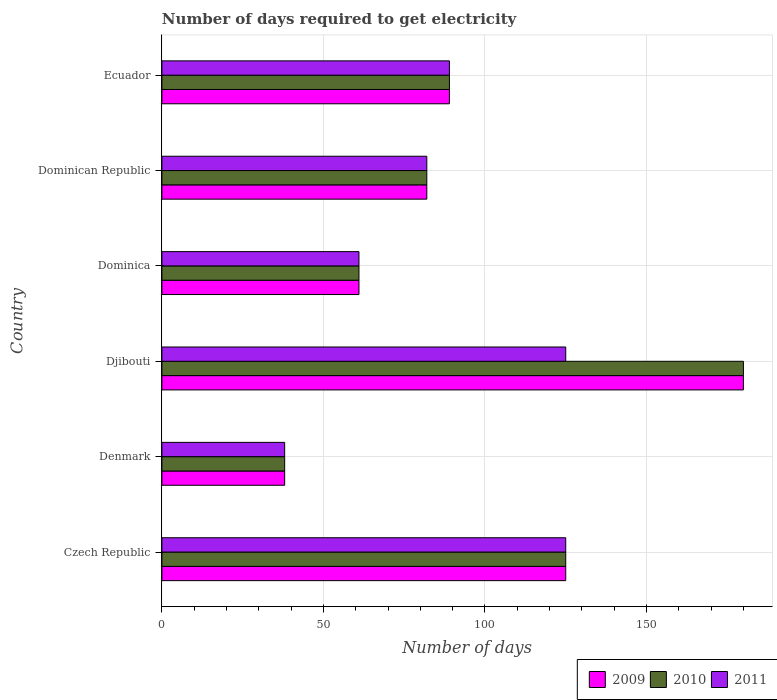How many different coloured bars are there?
Provide a succinct answer. 3. Are the number of bars per tick equal to the number of legend labels?
Your answer should be very brief. Yes. Are the number of bars on each tick of the Y-axis equal?
Keep it short and to the point. Yes. How many bars are there on the 6th tick from the top?
Give a very brief answer. 3. How many bars are there on the 4th tick from the bottom?
Your answer should be very brief. 3. What is the label of the 5th group of bars from the top?
Your response must be concise. Denmark. In how many cases, is the number of bars for a given country not equal to the number of legend labels?
Give a very brief answer. 0. What is the number of days required to get electricity in in 2010 in Denmark?
Offer a terse response. 38. Across all countries, what is the maximum number of days required to get electricity in in 2011?
Make the answer very short. 125. Across all countries, what is the minimum number of days required to get electricity in in 2010?
Keep it short and to the point. 38. In which country was the number of days required to get electricity in in 2009 maximum?
Your answer should be compact. Djibouti. In which country was the number of days required to get electricity in in 2009 minimum?
Your answer should be compact. Denmark. What is the total number of days required to get electricity in in 2009 in the graph?
Your answer should be very brief. 575. What is the average number of days required to get electricity in in 2010 per country?
Provide a short and direct response. 95.83. What is the difference between the number of days required to get electricity in in 2011 and number of days required to get electricity in in 2010 in Dominican Republic?
Your response must be concise. 0. In how many countries, is the number of days required to get electricity in in 2009 greater than 60 days?
Keep it short and to the point. 5. What is the ratio of the number of days required to get electricity in in 2009 in Denmark to that in Ecuador?
Ensure brevity in your answer.  0.43. Is the difference between the number of days required to get electricity in in 2011 in Czech Republic and Dominica greater than the difference between the number of days required to get electricity in in 2010 in Czech Republic and Dominica?
Your answer should be compact. No. What is the difference between the highest and the second highest number of days required to get electricity in in 2011?
Provide a short and direct response. 0. What is the difference between the highest and the lowest number of days required to get electricity in in 2011?
Make the answer very short. 87. In how many countries, is the number of days required to get electricity in in 2010 greater than the average number of days required to get electricity in in 2010 taken over all countries?
Your answer should be compact. 2. What does the 3rd bar from the top in Czech Republic represents?
Keep it short and to the point. 2009. What does the 3rd bar from the bottom in Czech Republic represents?
Keep it short and to the point. 2011. Is it the case that in every country, the sum of the number of days required to get electricity in in 2010 and number of days required to get electricity in in 2009 is greater than the number of days required to get electricity in in 2011?
Your answer should be compact. Yes. Are all the bars in the graph horizontal?
Your response must be concise. Yes. How many countries are there in the graph?
Provide a short and direct response. 6. How are the legend labels stacked?
Your answer should be compact. Horizontal. What is the title of the graph?
Make the answer very short. Number of days required to get electricity. Does "2003" appear as one of the legend labels in the graph?
Your answer should be compact. No. What is the label or title of the X-axis?
Offer a very short reply. Number of days. What is the label or title of the Y-axis?
Offer a terse response. Country. What is the Number of days in 2009 in Czech Republic?
Provide a succinct answer. 125. What is the Number of days in 2010 in Czech Republic?
Your answer should be compact. 125. What is the Number of days of 2011 in Czech Republic?
Your response must be concise. 125. What is the Number of days in 2009 in Denmark?
Your response must be concise. 38. What is the Number of days of 2009 in Djibouti?
Your response must be concise. 180. What is the Number of days in 2010 in Djibouti?
Your answer should be compact. 180. What is the Number of days in 2011 in Djibouti?
Provide a succinct answer. 125. What is the Number of days in 2009 in Dominica?
Provide a succinct answer. 61. What is the Number of days in 2010 in Dominica?
Your answer should be very brief. 61. What is the Number of days of 2011 in Dominica?
Ensure brevity in your answer.  61. What is the Number of days in 2010 in Dominican Republic?
Your answer should be very brief. 82. What is the Number of days in 2009 in Ecuador?
Offer a very short reply. 89. What is the Number of days of 2010 in Ecuador?
Provide a short and direct response. 89. What is the Number of days in 2011 in Ecuador?
Keep it short and to the point. 89. Across all countries, what is the maximum Number of days in 2009?
Your answer should be compact. 180. Across all countries, what is the maximum Number of days of 2010?
Give a very brief answer. 180. Across all countries, what is the maximum Number of days of 2011?
Your response must be concise. 125. Across all countries, what is the minimum Number of days in 2009?
Your answer should be compact. 38. Across all countries, what is the minimum Number of days in 2010?
Your answer should be very brief. 38. Across all countries, what is the minimum Number of days in 2011?
Provide a succinct answer. 38. What is the total Number of days of 2009 in the graph?
Provide a succinct answer. 575. What is the total Number of days of 2010 in the graph?
Offer a very short reply. 575. What is the total Number of days in 2011 in the graph?
Give a very brief answer. 520. What is the difference between the Number of days in 2009 in Czech Republic and that in Denmark?
Your answer should be very brief. 87. What is the difference between the Number of days in 2009 in Czech Republic and that in Djibouti?
Your answer should be compact. -55. What is the difference between the Number of days in 2010 in Czech Republic and that in Djibouti?
Offer a very short reply. -55. What is the difference between the Number of days of 2011 in Czech Republic and that in Djibouti?
Your response must be concise. 0. What is the difference between the Number of days in 2009 in Czech Republic and that in Dominica?
Your answer should be very brief. 64. What is the difference between the Number of days of 2011 in Czech Republic and that in Dominican Republic?
Provide a short and direct response. 43. What is the difference between the Number of days of 2009 in Czech Republic and that in Ecuador?
Offer a terse response. 36. What is the difference between the Number of days of 2011 in Czech Republic and that in Ecuador?
Your response must be concise. 36. What is the difference between the Number of days in 2009 in Denmark and that in Djibouti?
Offer a very short reply. -142. What is the difference between the Number of days of 2010 in Denmark and that in Djibouti?
Provide a succinct answer. -142. What is the difference between the Number of days in 2011 in Denmark and that in Djibouti?
Your answer should be compact. -87. What is the difference between the Number of days of 2009 in Denmark and that in Dominican Republic?
Offer a very short reply. -44. What is the difference between the Number of days in 2010 in Denmark and that in Dominican Republic?
Give a very brief answer. -44. What is the difference between the Number of days in 2011 in Denmark and that in Dominican Republic?
Your answer should be compact. -44. What is the difference between the Number of days in 2009 in Denmark and that in Ecuador?
Your answer should be very brief. -51. What is the difference between the Number of days of 2010 in Denmark and that in Ecuador?
Offer a terse response. -51. What is the difference between the Number of days in 2011 in Denmark and that in Ecuador?
Give a very brief answer. -51. What is the difference between the Number of days of 2009 in Djibouti and that in Dominica?
Make the answer very short. 119. What is the difference between the Number of days in 2010 in Djibouti and that in Dominica?
Ensure brevity in your answer.  119. What is the difference between the Number of days of 2011 in Djibouti and that in Dominica?
Offer a terse response. 64. What is the difference between the Number of days in 2011 in Djibouti and that in Dominican Republic?
Offer a very short reply. 43. What is the difference between the Number of days of 2009 in Djibouti and that in Ecuador?
Offer a very short reply. 91. What is the difference between the Number of days of 2010 in Djibouti and that in Ecuador?
Keep it short and to the point. 91. What is the difference between the Number of days in 2010 in Dominica and that in Dominican Republic?
Offer a terse response. -21. What is the difference between the Number of days in 2011 in Dominica and that in Dominican Republic?
Ensure brevity in your answer.  -21. What is the difference between the Number of days of 2010 in Dominica and that in Ecuador?
Keep it short and to the point. -28. What is the difference between the Number of days of 2011 in Dominica and that in Ecuador?
Your answer should be very brief. -28. What is the difference between the Number of days in 2010 in Czech Republic and the Number of days in 2011 in Denmark?
Make the answer very short. 87. What is the difference between the Number of days in 2009 in Czech Republic and the Number of days in 2010 in Djibouti?
Keep it short and to the point. -55. What is the difference between the Number of days in 2010 in Czech Republic and the Number of days in 2011 in Djibouti?
Give a very brief answer. 0. What is the difference between the Number of days of 2009 in Czech Republic and the Number of days of 2010 in Dominican Republic?
Give a very brief answer. 43. What is the difference between the Number of days in 2009 in Czech Republic and the Number of days in 2011 in Dominican Republic?
Make the answer very short. 43. What is the difference between the Number of days of 2010 in Czech Republic and the Number of days of 2011 in Dominican Republic?
Make the answer very short. 43. What is the difference between the Number of days in 2009 in Czech Republic and the Number of days in 2010 in Ecuador?
Your answer should be compact. 36. What is the difference between the Number of days of 2010 in Czech Republic and the Number of days of 2011 in Ecuador?
Keep it short and to the point. 36. What is the difference between the Number of days of 2009 in Denmark and the Number of days of 2010 in Djibouti?
Provide a short and direct response. -142. What is the difference between the Number of days in 2009 in Denmark and the Number of days in 2011 in Djibouti?
Provide a short and direct response. -87. What is the difference between the Number of days in 2010 in Denmark and the Number of days in 2011 in Djibouti?
Make the answer very short. -87. What is the difference between the Number of days of 2009 in Denmark and the Number of days of 2010 in Dominica?
Make the answer very short. -23. What is the difference between the Number of days in 2009 in Denmark and the Number of days in 2011 in Dominica?
Your answer should be compact. -23. What is the difference between the Number of days of 2010 in Denmark and the Number of days of 2011 in Dominica?
Offer a terse response. -23. What is the difference between the Number of days of 2009 in Denmark and the Number of days of 2010 in Dominican Republic?
Your response must be concise. -44. What is the difference between the Number of days of 2009 in Denmark and the Number of days of 2011 in Dominican Republic?
Make the answer very short. -44. What is the difference between the Number of days in 2010 in Denmark and the Number of days in 2011 in Dominican Republic?
Your answer should be compact. -44. What is the difference between the Number of days of 2009 in Denmark and the Number of days of 2010 in Ecuador?
Give a very brief answer. -51. What is the difference between the Number of days in 2009 in Denmark and the Number of days in 2011 in Ecuador?
Your answer should be compact. -51. What is the difference between the Number of days in 2010 in Denmark and the Number of days in 2011 in Ecuador?
Offer a very short reply. -51. What is the difference between the Number of days of 2009 in Djibouti and the Number of days of 2010 in Dominica?
Keep it short and to the point. 119. What is the difference between the Number of days of 2009 in Djibouti and the Number of days of 2011 in Dominica?
Your response must be concise. 119. What is the difference between the Number of days in 2010 in Djibouti and the Number of days in 2011 in Dominica?
Your answer should be very brief. 119. What is the difference between the Number of days in 2009 in Djibouti and the Number of days in 2010 in Ecuador?
Offer a very short reply. 91. What is the difference between the Number of days of 2009 in Djibouti and the Number of days of 2011 in Ecuador?
Your answer should be compact. 91. What is the difference between the Number of days in 2010 in Djibouti and the Number of days in 2011 in Ecuador?
Give a very brief answer. 91. What is the difference between the Number of days of 2009 in Dominica and the Number of days of 2010 in Dominican Republic?
Keep it short and to the point. -21. What is the difference between the Number of days of 2010 in Dominica and the Number of days of 2011 in Dominican Republic?
Offer a very short reply. -21. What is the difference between the Number of days in 2009 in Dominica and the Number of days in 2010 in Ecuador?
Give a very brief answer. -28. What is the difference between the Number of days in 2010 in Dominica and the Number of days in 2011 in Ecuador?
Ensure brevity in your answer.  -28. What is the difference between the Number of days in 2009 in Dominican Republic and the Number of days in 2010 in Ecuador?
Keep it short and to the point. -7. What is the difference between the Number of days in 2010 in Dominican Republic and the Number of days in 2011 in Ecuador?
Your answer should be compact. -7. What is the average Number of days of 2009 per country?
Give a very brief answer. 95.83. What is the average Number of days of 2010 per country?
Keep it short and to the point. 95.83. What is the average Number of days of 2011 per country?
Offer a terse response. 86.67. What is the difference between the Number of days in 2009 and Number of days in 2010 in Czech Republic?
Offer a very short reply. 0. What is the difference between the Number of days of 2009 and Number of days of 2011 in Czech Republic?
Your response must be concise. 0. What is the difference between the Number of days of 2010 and Number of days of 2011 in Czech Republic?
Keep it short and to the point. 0. What is the difference between the Number of days in 2009 and Number of days in 2010 in Denmark?
Your answer should be very brief. 0. What is the difference between the Number of days in 2009 and Number of days in 2011 in Denmark?
Make the answer very short. 0. What is the difference between the Number of days of 2010 and Number of days of 2011 in Denmark?
Keep it short and to the point. 0. What is the difference between the Number of days in 2009 and Number of days in 2011 in Dominican Republic?
Provide a succinct answer. 0. What is the difference between the Number of days in 2009 and Number of days in 2011 in Ecuador?
Offer a very short reply. 0. What is the difference between the Number of days in 2010 and Number of days in 2011 in Ecuador?
Offer a very short reply. 0. What is the ratio of the Number of days in 2009 in Czech Republic to that in Denmark?
Ensure brevity in your answer.  3.29. What is the ratio of the Number of days in 2010 in Czech Republic to that in Denmark?
Give a very brief answer. 3.29. What is the ratio of the Number of days in 2011 in Czech Republic to that in Denmark?
Keep it short and to the point. 3.29. What is the ratio of the Number of days in 2009 in Czech Republic to that in Djibouti?
Keep it short and to the point. 0.69. What is the ratio of the Number of days in 2010 in Czech Republic to that in Djibouti?
Keep it short and to the point. 0.69. What is the ratio of the Number of days in 2009 in Czech Republic to that in Dominica?
Provide a short and direct response. 2.05. What is the ratio of the Number of days of 2010 in Czech Republic to that in Dominica?
Give a very brief answer. 2.05. What is the ratio of the Number of days in 2011 in Czech Republic to that in Dominica?
Offer a terse response. 2.05. What is the ratio of the Number of days of 2009 in Czech Republic to that in Dominican Republic?
Provide a succinct answer. 1.52. What is the ratio of the Number of days in 2010 in Czech Republic to that in Dominican Republic?
Provide a short and direct response. 1.52. What is the ratio of the Number of days of 2011 in Czech Republic to that in Dominican Republic?
Provide a short and direct response. 1.52. What is the ratio of the Number of days in 2009 in Czech Republic to that in Ecuador?
Make the answer very short. 1.4. What is the ratio of the Number of days in 2010 in Czech Republic to that in Ecuador?
Your response must be concise. 1.4. What is the ratio of the Number of days in 2011 in Czech Republic to that in Ecuador?
Keep it short and to the point. 1.4. What is the ratio of the Number of days of 2009 in Denmark to that in Djibouti?
Provide a succinct answer. 0.21. What is the ratio of the Number of days of 2010 in Denmark to that in Djibouti?
Provide a short and direct response. 0.21. What is the ratio of the Number of days in 2011 in Denmark to that in Djibouti?
Offer a terse response. 0.3. What is the ratio of the Number of days in 2009 in Denmark to that in Dominica?
Give a very brief answer. 0.62. What is the ratio of the Number of days in 2010 in Denmark to that in Dominica?
Make the answer very short. 0.62. What is the ratio of the Number of days in 2011 in Denmark to that in Dominica?
Provide a succinct answer. 0.62. What is the ratio of the Number of days in 2009 in Denmark to that in Dominican Republic?
Your response must be concise. 0.46. What is the ratio of the Number of days of 2010 in Denmark to that in Dominican Republic?
Give a very brief answer. 0.46. What is the ratio of the Number of days in 2011 in Denmark to that in Dominican Republic?
Give a very brief answer. 0.46. What is the ratio of the Number of days of 2009 in Denmark to that in Ecuador?
Provide a succinct answer. 0.43. What is the ratio of the Number of days of 2010 in Denmark to that in Ecuador?
Your answer should be compact. 0.43. What is the ratio of the Number of days in 2011 in Denmark to that in Ecuador?
Offer a terse response. 0.43. What is the ratio of the Number of days of 2009 in Djibouti to that in Dominica?
Make the answer very short. 2.95. What is the ratio of the Number of days in 2010 in Djibouti to that in Dominica?
Offer a terse response. 2.95. What is the ratio of the Number of days of 2011 in Djibouti to that in Dominica?
Give a very brief answer. 2.05. What is the ratio of the Number of days in 2009 in Djibouti to that in Dominican Republic?
Keep it short and to the point. 2.2. What is the ratio of the Number of days in 2010 in Djibouti to that in Dominican Republic?
Offer a terse response. 2.2. What is the ratio of the Number of days in 2011 in Djibouti to that in Dominican Republic?
Offer a very short reply. 1.52. What is the ratio of the Number of days of 2009 in Djibouti to that in Ecuador?
Provide a short and direct response. 2.02. What is the ratio of the Number of days in 2010 in Djibouti to that in Ecuador?
Offer a very short reply. 2.02. What is the ratio of the Number of days of 2011 in Djibouti to that in Ecuador?
Your answer should be compact. 1.4. What is the ratio of the Number of days of 2009 in Dominica to that in Dominican Republic?
Make the answer very short. 0.74. What is the ratio of the Number of days of 2010 in Dominica to that in Dominican Republic?
Keep it short and to the point. 0.74. What is the ratio of the Number of days of 2011 in Dominica to that in Dominican Republic?
Your response must be concise. 0.74. What is the ratio of the Number of days of 2009 in Dominica to that in Ecuador?
Your answer should be very brief. 0.69. What is the ratio of the Number of days in 2010 in Dominica to that in Ecuador?
Make the answer very short. 0.69. What is the ratio of the Number of days of 2011 in Dominica to that in Ecuador?
Keep it short and to the point. 0.69. What is the ratio of the Number of days in 2009 in Dominican Republic to that in Ecuador?
Offer a very short reply. 0.92. What is the ratio of the Number of days in 2010 in Dominican Republic to that in Ecuador?
Offer a terse response. 0.92. What is the ratio of the Number of days in 2011 in Dominican Republic to that in Ecuador?
Your response must be concise. 0.92. What is the difference between the highest and the second highest Number of days in 2009?
Your response must be concise. 55. What is the difference between the highest and the lowest Number of days in 2009?
Provide a succinct answer. 142. What is the difference between the highest and the lowest Number of days in 2010?
Keep it short and to the point. 142. 